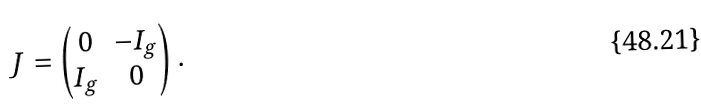Convert formula to latex. <formula><loc_0><loc_0><loc_500><loc_500>J = \begin{pmatrix} 0 & - I _ { g } \\ I _ { g } & 0 \end{pmatrix} .</formula> 